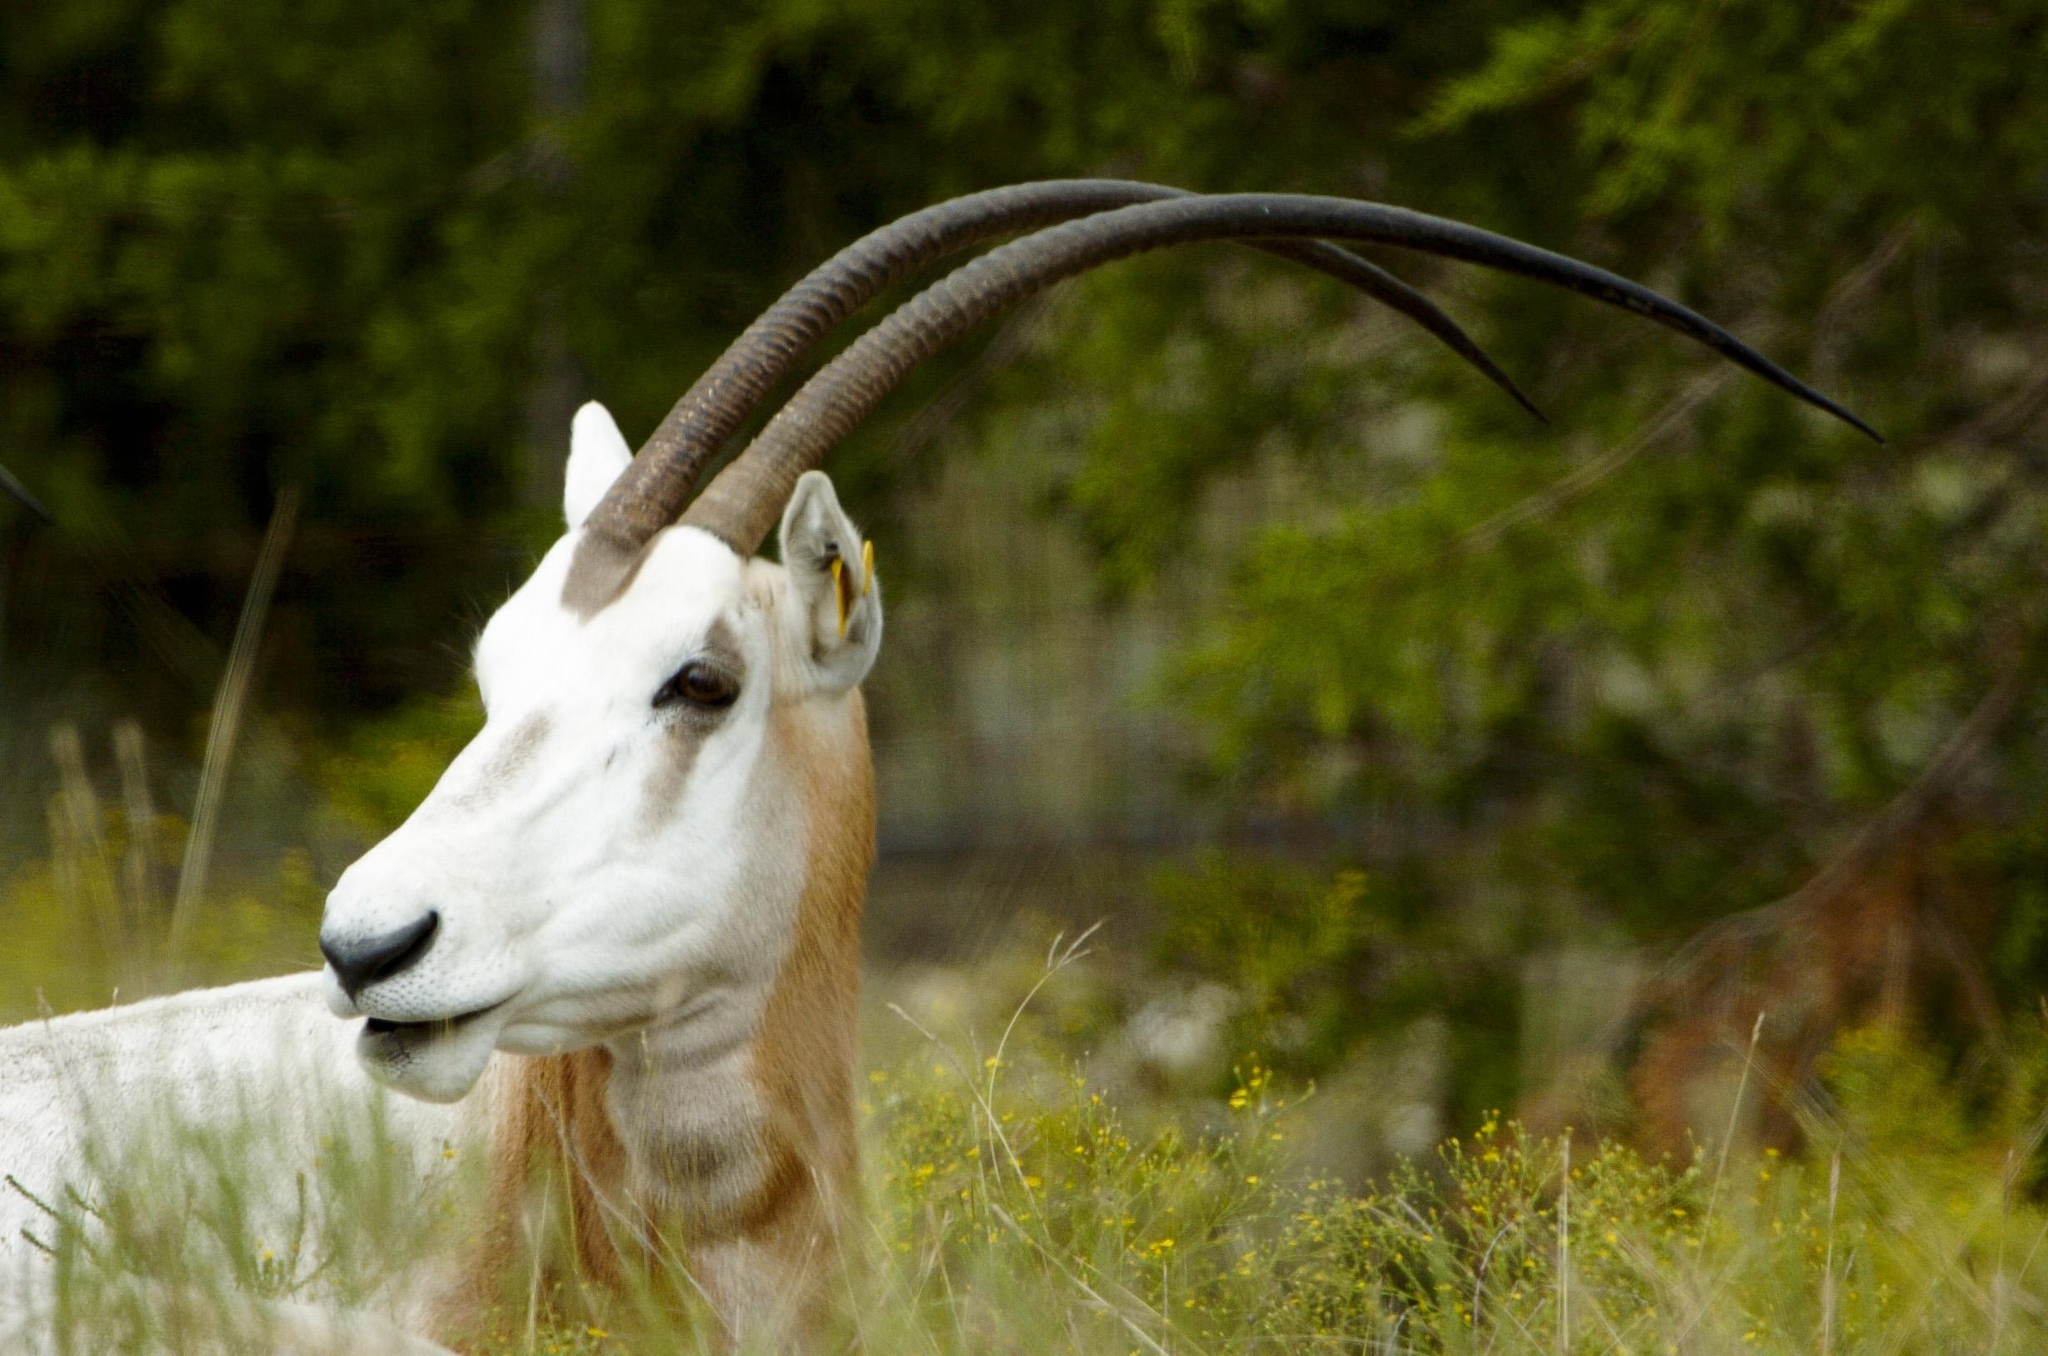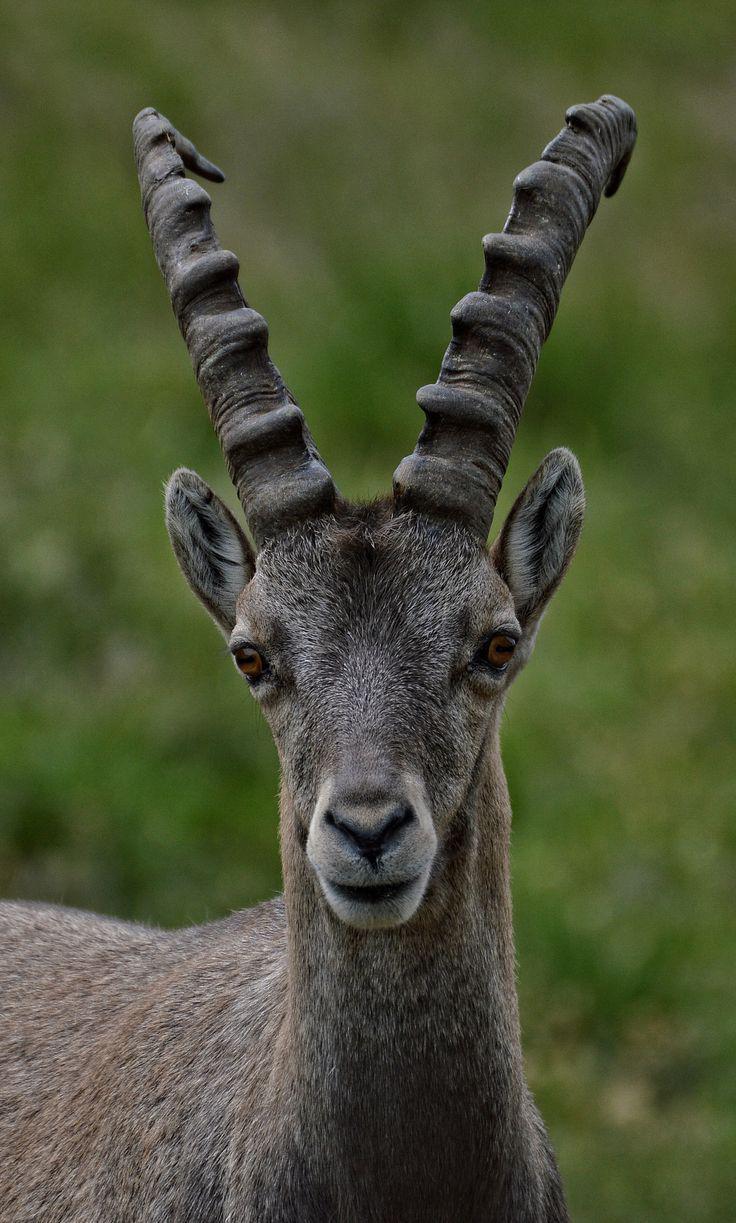The first image is the image on the left, the second image is the image on the right. Given the left and right images, does the statement "An image shows one horned animal standing on dark rocks." hold true? Answer yes or no. No. The first image is the image on the left, the second image is the image on the right. Examine the images to the left and right. Is the description "The mountain goat in the right image is standing on a steep rocky mountain." accurate? Answer yes or no. No. 